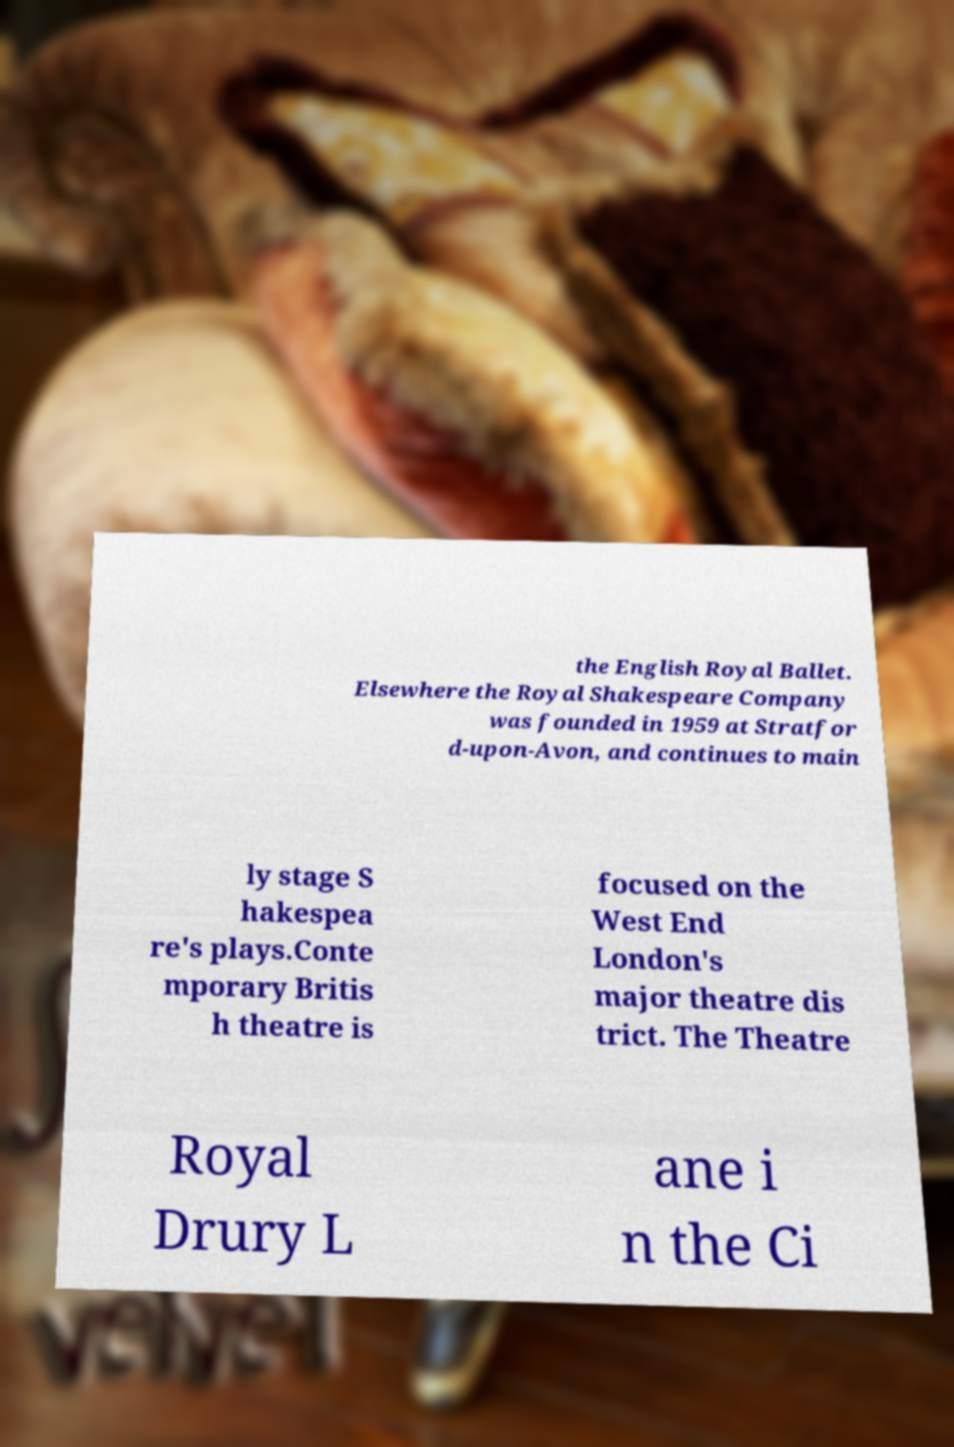Can you accurately transcribe the text from the provided image for me? the English Royal Ballet. Elsewhere the Royal Shakespeare Company was founded in 1959 at Stratfor d-upon-Avon, and continues to main ly stage S hakespea re's plays.Conte mporary Britis h theatre is focused on the West End London's major theatre dis trict. The Theatre Royal Drury L ane i n the Ci 